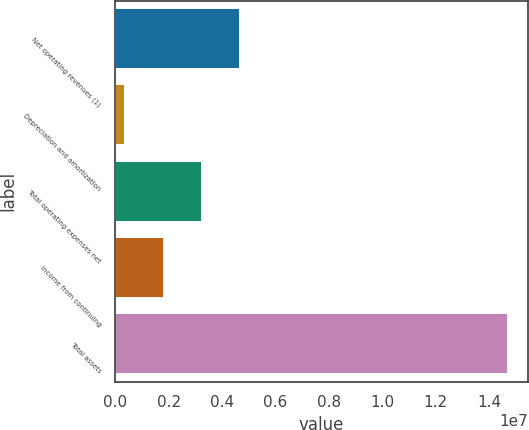Convert chart. <chart><loc_0><loc_0><loc_500><loc_500><bar_chart><fcel>Net operating revenues (1)<fcel>Depreciation and amortization<fcel>Total operating expenses net<fcel>Income from continuing<fcel>Total assets<nl><fcel>4.68197e+06<fcel>380402<fcel>3.24812e+06<fcel>1.81426e+06<fcel>1.4719e+07<nl></chart> 